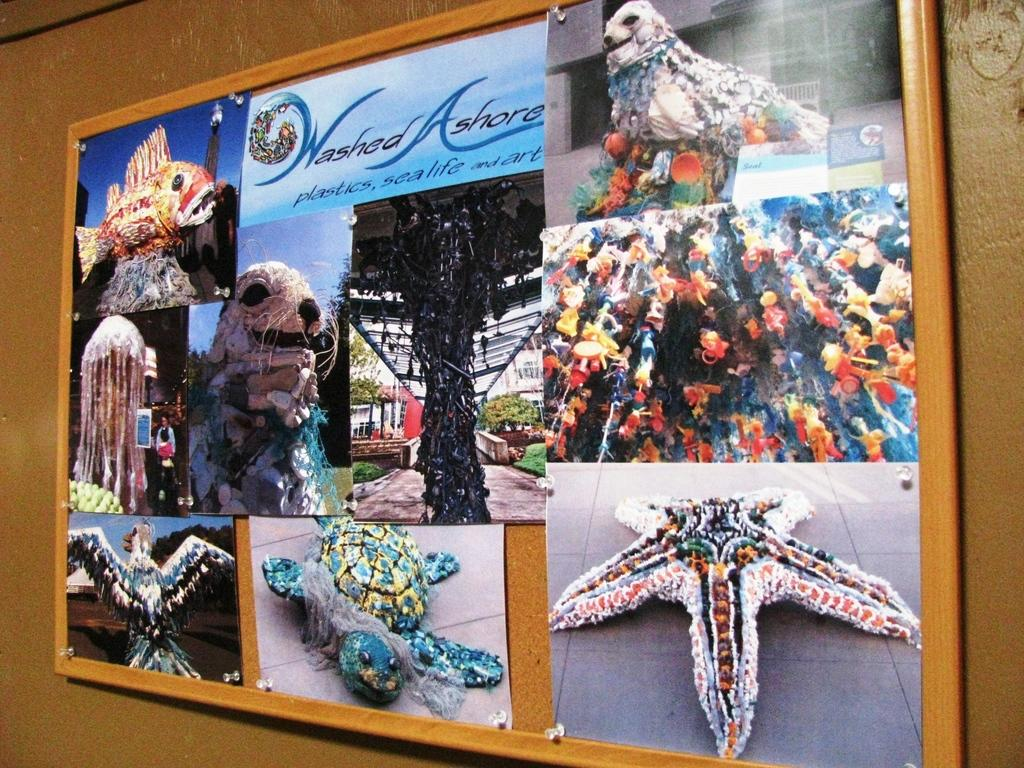What is the main object in the image? There is a board in the image. What can be seen on the board? The board has pictures and text on it. Where is the board located? The board is on a wall. How many cows are standing in the shade on the board? There are no cows or shaded areas depicted on the board; it only features pictures and text. 